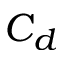Convert formula to latex. <formula><loc_0><loc_0><loc_500><loc_500>C _ { d }</formula> 